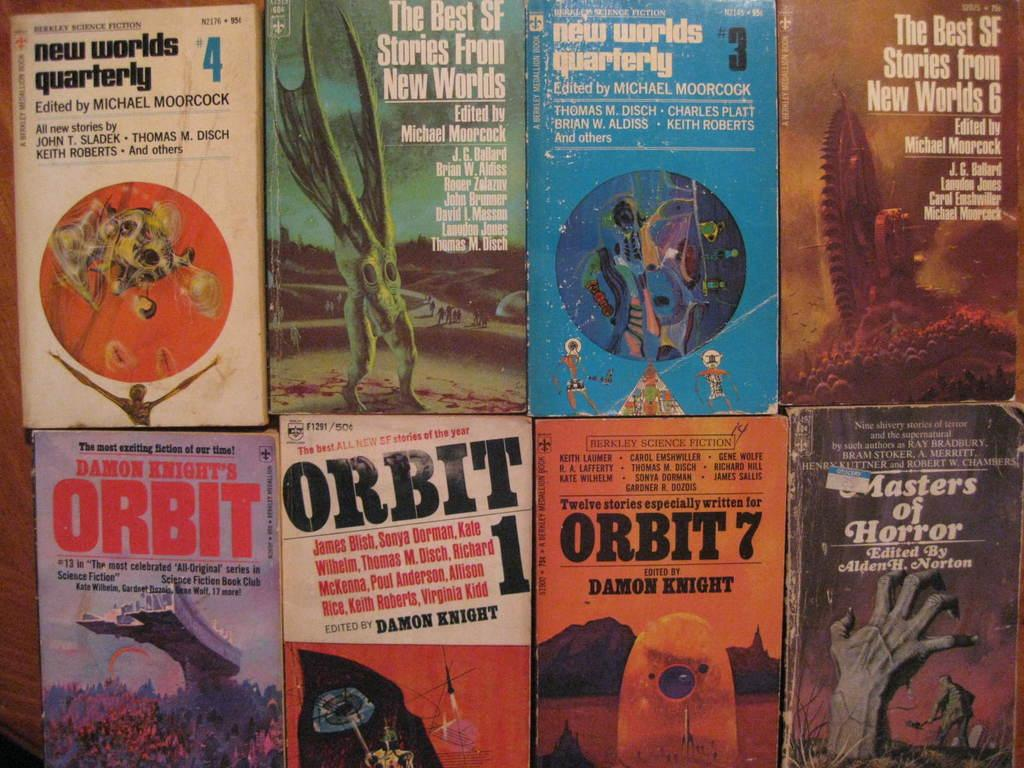Provide a one-sentence caption for the provided image. Eight books with the word Orbit in them. 